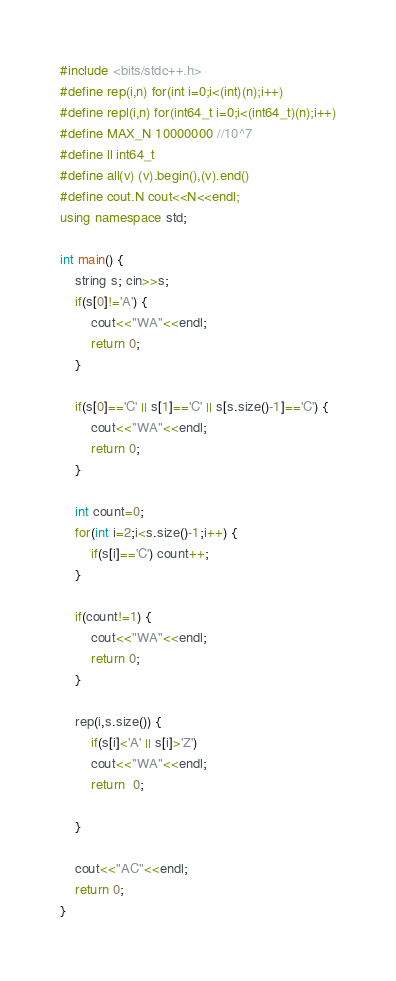Convert code to text. <code><loc_0><loc_0><loc_500><loc_500><_C++_>#include <bits/stdc++.h>
#define rep(i,n) for(int i=0;i<(int)(n);i++)
#define repl(i,n) for(int64_t i=0;i<(int64_t)(n);i++)
#define MAX_N 10000000 //10^7
#define ll int64_t
#define all(v) (v).begin(),(v).end()
#define cout.N cout<<N<<endl;
using namespace std;

int main() {
    string s; cin>>s;
    if(s[0]!='A') {
        cout<<"WA"<<endl;
        return 0;
    }

    if(s[0]=='C' || s[1]=='C' || s[s.size()-1]=='C') {
        cout<<"WA"<<endl;
        return 0;
    }

    int count=0;
    for(int i=2;i<s.size()-1;i++) {
        if(s[i]=='C') count++;
    }

    if(count!=1) {
        cout<<"WA"<<endl;
        return 0;
    }

    rep(i,s.size()) {
        if(s[i]<'A' || s[i]>'Z')
        cout<<"WA"<<endl;
        return  0;
        
    }
    
    cout<<"AC"<<endl;
    return 0;
}</code> 